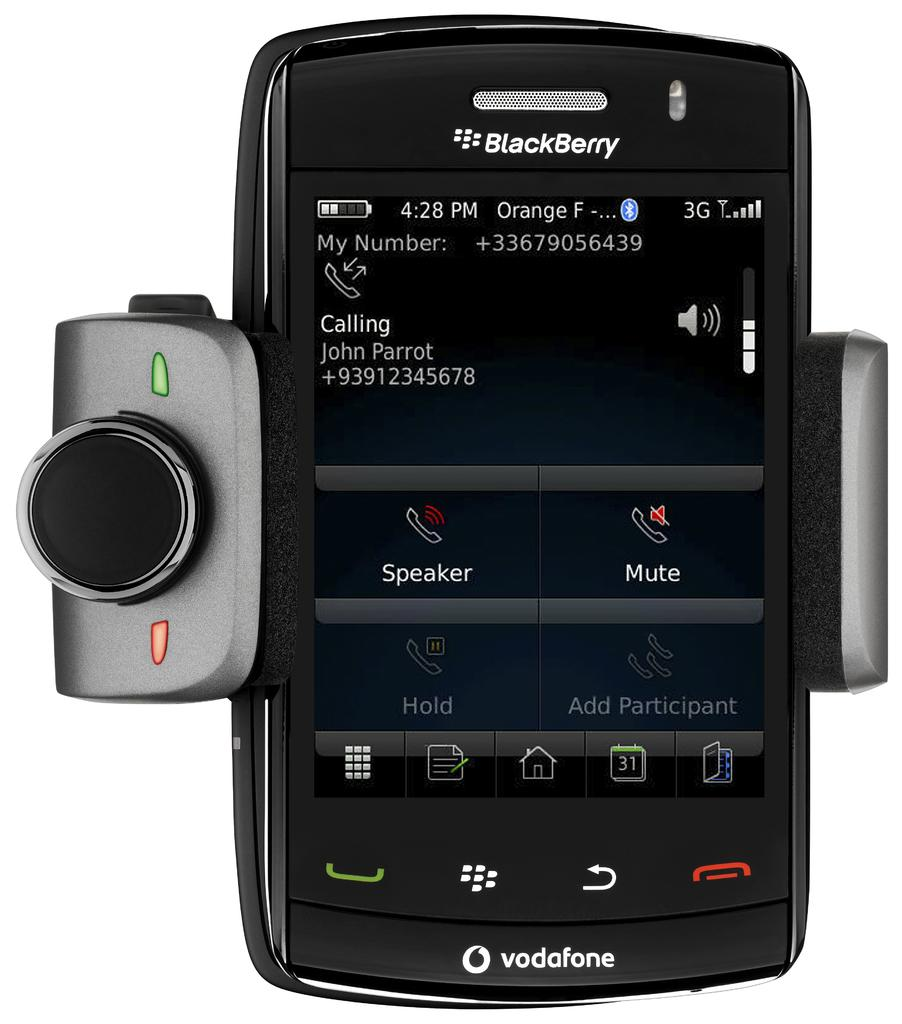What object is the main subject of the image? There is a cell phone in the image. What feature is attached to the cell phone? The cell phone has a lens attached to it. What color is the background of the image? The background of the image is white. What can be seen on the cell phone screen? There is text and icons visible on the cell phone screen. What type of marble is visible on the cell phone screen? There is no marble visible on the cell phone screen; it displays text and icons. Can you see the person smiling while using the cell phone in the image? There is no person visible in the image, so it is impossible to determine if they are smiling or not. 